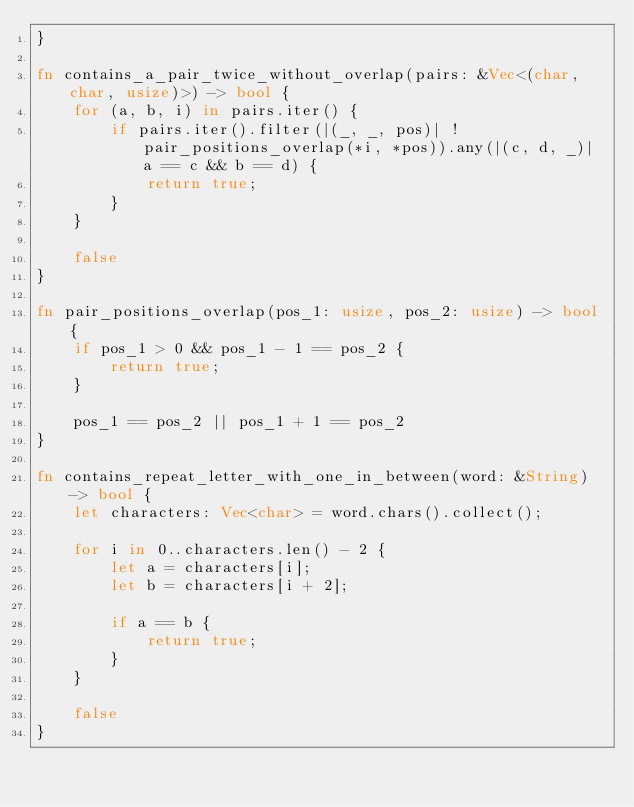Convert code to text. <code><loc_0><loc_0><loc_500><loc_500><_Rust_>}

fn contains_a_pair_twice_without_overlap(pairs: &Vec<(char, char, usize)>) -> bool {
    for (a, b, i) in pairs.iter() {
        if pairs.iter().filter(|(_, _, pos)| !pair_positions_overlap(*i, *pos)).any(|(c, d, _)| a == c && b == d) {
            return true;
        }
    }

    false
}

fn pair_positions_overlap(pos_1: usize, pos_2: usize) -> bool {
    if pos_1 > 0 && pos_1 - 1 == pos_2 {
        return true;
    }

    pos_1 == pos_2 || pos_1 + 1 == pos_2
}

fn contains_repeat_letter_with_one_in_between(word: &String) -> bool {
    let characters: Vec<char> = word.chars().collect();

    for i in 0..characters.len() - 2 {
        let a = characters[i];
        let b = characters[i + 2];

        if a == b {
            return true;
        }
    }

    false
}</code> 